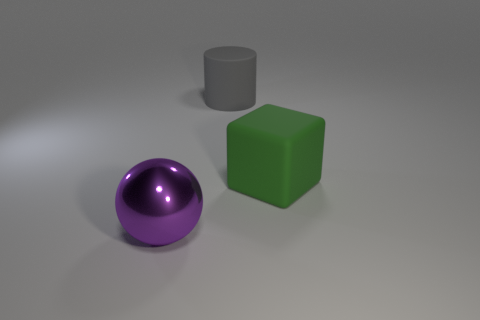Is there any other thing that has the same size as the green matte object?
Your answer should be compact. Yes. Is the material of the thing in front of the green thing the same as the big green object?
Offer a very short reply. No. What number of other things are there of the same color as the large ball?
Keep it short and to the point. 0. There is a object behind the large green rubber block; is it the same shape as the object on the left side of the large gray matte thing?
Provide a succinct answer. No. How many cylinders are either small brown shiny things or gray rubber things?
Give a very brief answer. 1. Is the number of big gray rubber cylinders that are in front of the gray rubber cylinder less than the number of big purple things?
Provide a succinct answer. Yes. How many other things are made of the same material as the big sphere?
Keep it short and to the point. 0. Do the green block and the rubber cylinder have the same size?
Your response must be concise. Yes. How many things are either large things that are to the right of the big sphere or purple rubber balls?
Keep it short and to the point. 2. What is the big object that is to the left of the large matte thing behind the green block made of?
Give a very brief answer. Metal. 